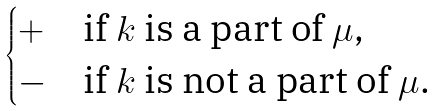<formula> <loc_0><loc_0><loc_500><loc_500>\begin{cases} + & \text {if $k$ is a part of $\mu$,} \\ - & \text {if $k$ is not a part of $\mu$.} \end{cases}</formula> 